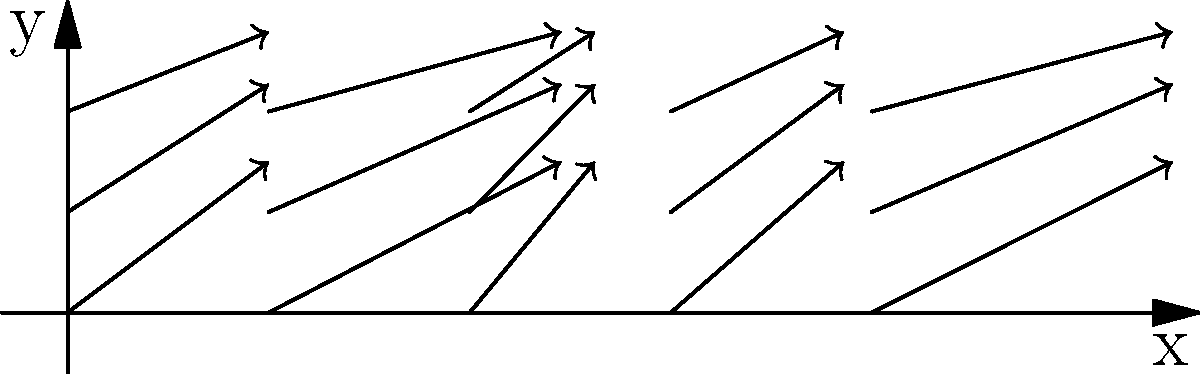A wind pattern is modeled by the vector field $\mathbf{F}(x,y) = (2+\sin x)\mathbf{i} + (1+0.5\cos y)\mathbf{j}$. If pollen from a rare plant species is released at the origin (0,0), in which direction will it initially travel? Express your answer as a unit vector. To determine the initial direction of pollen travel, we need to follow these steps:

1) The pollen is released at the origin (0,0), so we need to evaluate the vector field at this point.

2) Evaluate $\mathbf{F}(0,0)$:
   $\mathbf{F}(0,0) = (2+\sin 0)\mathbf{i} + (1+0.5\cos 0)\mathbf{j}$
   $= 2\mathbf{i} + 1.5\mathbf{j}$

3) This vector $(2, 1.5)$ gives us the direction of initial travel, but we need to express it as a unit vector.

4) To convert to a unit vector, we divide by the magnitude of the vector:
   $\|(2, 1.5)\| = \sqrt{2^2 + 1.5^2} = \sqrt{4 + 2.25} = \sqrt{6.25} = 2.5$

5) The unit vector is thus:
   $\frac{(2, 1.5)}{2.5} = (0.8, 0.6)$

Therefore, the pollen will initially travel in the direction of the unit vector $(0.8, 0.6)$.
Answer: $(0.8\mathbf{i} + 0.6\mathbf{j})$ 